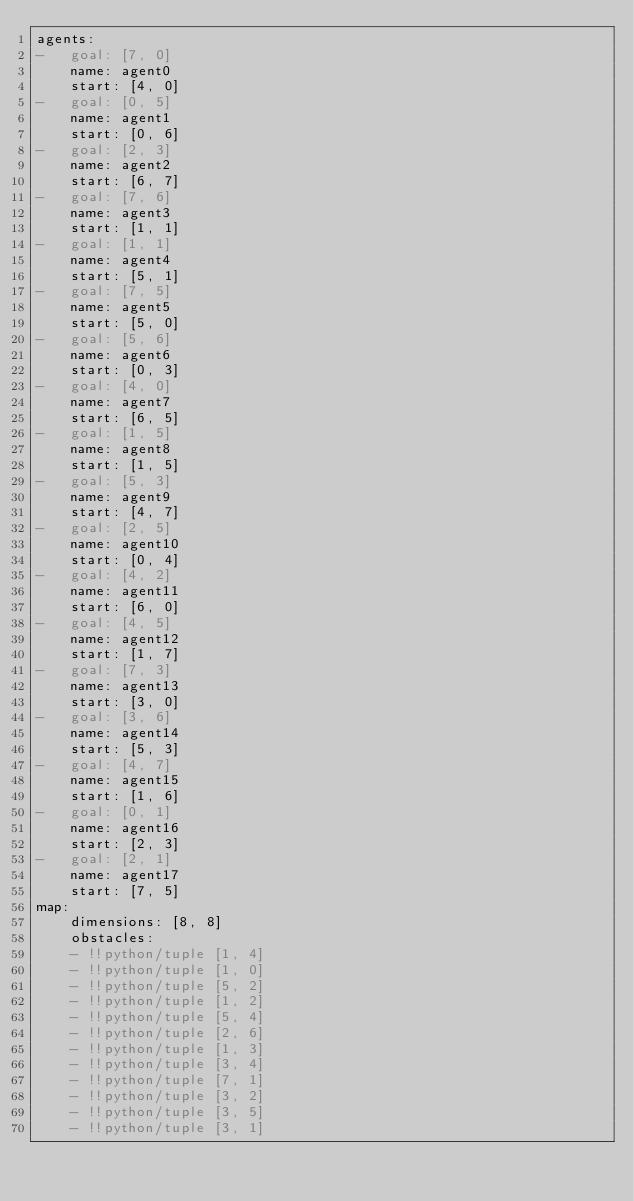<code> <loc_0><loc_0><loc_500><loc_500><_YAML_>agents:
-   goal: [7, 0]
    name: agent0
    start: [4, 0]
-   goal: [0, 5]
    name: agent1
    start: [0, 6]
-   goal: [2, 3]
    name: agent2
    start: [6, 7]
-   goal: [7, 6]
    name: agent3
    start: [1, 1]
-   goal: [1, 1]
    name: agent4
    start: [5, 1]
-   goal: [7, 5]
    name: agent5
    start: [5, 0]
-   goal: [5, 6]
    name: agent6
    start: [0, 3]
-   goal: [4, 0]
    name: agent7
    start: [6, 5]
-   goal: [1, 5]
    name: agent8
    start: [1, 5]
-   goal: [5, 3]
    name: agent9
    start: [4, 7]
-   goal: [2, 5]
    name: agent10
    start: [0, 4]
-   goal: [4, 2]
    name: agent11
    start: [6, 0]
-   goal: [4, 5]
    name: agent12
    start: [1, 7]
-   goal: [7, 3]
    name: agent13
    start: [3, 0]
-   goal: [3, 6]
    name: agent14
    start: [5, 3]
-   goal: [4, 7]
    name: agent15
    start: [1, 6]
-   goal: [0, 1]
    name: agent16
    start: [2, 3]
-   goal: [2, 1]
    name: agent17
    start: [7, 5]
map:
    dimensions: [8, 8]
    obstacles:
    - !!python/tuple [1, 4]
    - !!python/tuple [1, 0]
    - !!python/tuple [5, 2]
    - !!python/tuple [1, 2]
    - !!python/tuple [5, 4]
    - !!python/tuple [2, 6]
    - !!python/tuple [1, 3]
    - !!python/tuple [3, 4]
    - !!python/tuple [7, 1]
    - !!python/tuple [3, 2]
    - !!python/tuple [3, 5]
    - !!python/tuple [3, 1]
</code> 